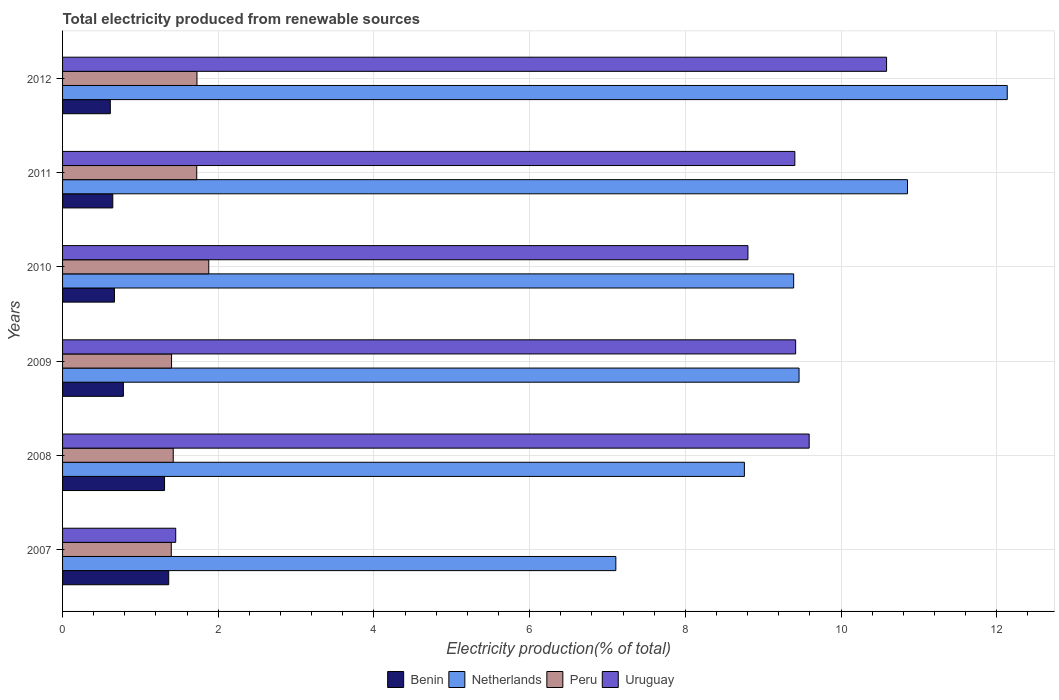How many different coloured bars are there?
Ensure brevity in your answer.  4. Are the number of bars on each tick of the Y-axis equal?
Offer a terse response. Yes. How many bars are there on the 6th tick from the top?
Give a very brief answer. 4. How many bars are there on the 5th tick from the bottom?
Give a very brief answer. 4. What is the label of the 4th group of bars from the top?
Give a very brief answer. 2009. What is the total electricity produced in Uruguay in 2007?
Your response must be concise. 1.45. Across all years, what is the maximum total electricity produced in Netherlands?
Ensure brevity in your answer.  12.14. Across all years, what is the minimum total electricity produced in Benin?
Make the answer very short. 0.61. In which year was the total electricity produced in Benin maximum?
Provide a succinct answer. 2007. In which year was the total electricity produced in Netherlands minimum?
Give a very brief answer. 2007. What is the total total electricity produced in Benin in the graph?
Your answer should be compact. 5.38. What is the difference between the total electricity produced in Benin in 2007 and that in 2009?
Your answer should be compact. 0.58. What is the difference between the total electricity produced in Uruguay in 2010 and the total electricity produced in Peru in 2012?
Provide a succinct answer. 7.08. What is the average total electricity produced in Peru per year?
Provide a succinct answer. 1.59. In the year 2009, what is the difference between the total electricity produced in Netherlands and total electricity produced in Uruguay?
Offer a terse response. 0.04. In how many years, is the total electricity produced in Uruguay greater than 2.4 %?
Provide a succinct answer. 5. What is the ratio of the total electricity produced in Benin in 2009 to that in 2012?
Keep it short and to the point. 1.27. What is the difference between the highest and the second highest total electricity produced in Peru?
Your answer should be very brief. 0.15. What is the difference between the highest and the lowest total electricity produced in Benin?
Your answer should be compact. 0.75. Is the sum of the total electricity produced in Uruguay in 2009 and 2011 greater than the maximum total electricity produced in Benin across all years?
Provide a succinct answer. Yes. Is it the case that in every year, the sum of the total electricity produced in Benin and total electricity produced in Uruguay is greater than the sum of total electricity produced in Peru and total electricity produced in Netherlands?
Keep it short and to the point. No. What does the 2nd bar from the top in 2012 represents?
Your answer should be very brief. Peru. How many bars are there?
Your answer should be compact. 24. Are all the bars in the graph horizontal?
Make the answer very short. Yes. Are the values on the major ticks of X-axis written in scientific E-notation?
Offer a terse response. No. How many legend labels are there?
Make the answer very short. 4. What is the title of the graph?
Your response must be concise. Total electricity produced from renewable sources. Does "Singapore" appear as one of the legend labels in the graph?
Your answer should be compact. No. What is the Electricity production(% of total) of Benin in 2007?
Your response must be concise. 1.36. What is the Electricity production(% of total) of Netherlands in 2007?
Ensure brevity in your answer.  7.11. What is the Electricity production(% of total) in Peru in 2007?
Keep it short and to the point. 1.4. What is the Electricity production(% of total) of Uruguay in 2007?
Make the answer very short. 1.45. What is the Electricity production(% of total) in Benin in 2008?
Provide a succinct answer. 1.31. What is the Electricity production(% of total) in Netherlands in 2008?
Your answer should be compact. 8.76. What is the Electricity production(% of total) in Peru in 2008?
Ensure brevity in your answer.  1.42. What is the Electricity production(% of total) of Uruguay in 2008?
Offer a very short reply. 9.59. What is the Electricity production(% of total) of Benin in 2009?
Your response must be concise. 0.78. What is the Electricity production(% of total) in Netherlands in 2009?
Ensure brevity in your answer.  9.46. What is the Electricity production(% of total) in Peru in 2009?
Give a very brief answer. 1.4. What is the Electricity production(% of total) of Uruguay in 2009?
Offer a terse response. 9.42. What is the Electricity production(% of total) of Benin in 2010?
Offer a terse response. 0.67. What is the Electricity production(% of total) in Netherlands in 2010?
Your answer should be very brief. 9.39. What is the Electricity production(% of total) in Peru in 2010?
Provide a short and direct response. 1.88. What is the Electricity production(% of total) of Uruguay in 2010?
Your answer should be very brief. 8.8. What is the Electricity production(% of total) of Benin in 2011?
Provide a short and direct response. 0.65. What is the Electricity production(% of total) of Netherlands in 2011?
Give a very brief answer. 10.85. What is the Electricity production(% of total) in Peru in 2011?
Offer a terse response. 1.72. What is the Electricity production(% of total) of Uruguay in 2011?
Offer a terse response. 9.41. What is the Electricity production(% of total) of Benin in 2012?
Provide a succinct answer. 0.61. What is the Electricity production(% of total) in Netherlands in 2012?
Your answer should be compact. 12.14. What is the Electricity production(% of total) in Peru in 2012?
Your answer should be very brief. 1.73. What is the Electricity production(% of total) of Uruguay in 2012?
Your response must be concise. 10.58. Across all years, what is the maximum Electricity production(% of total) in Benin?
Make the answer very short. 1.36. Across all years, what is the maximum Electricity production(% of total) of Netherlands?
Keep it short and to the point. 12.14. Across all years, what is the maximum Electricity production(% of total) in Peru?
Your answer should be compact. 1.88. Across all years, what is the maximum Electricity production(% of total) in Uruguay?
Give a very brief answer. 10.58. Across all years, what is the minimum Electricity production(% of total) in Benin?
Your response must be concise. 0.61. Across all years, what is the minimum Electricity production(% of total) in Netherlands?
Make the answer very short. 7.11. Across all years, what is the minimum Electricity production(% of total) in Peru?
Ensure brevity in your answer.  1.4. Across all years, what is the minimum Electricity production(% of total) in Uruguay?
Keep it short and to the point. 1.45. What is the total Electricity production(% of total) in Benin in the graph?
Your response must be concise. 5.38. What is the total Electricity production(% of total) in Netherlands in the graph?
Your response must be concise. 57.71. What is the total Electricity production(% of total) of Peru in the graph?
Your answer should be compact. 9.55. What is the total Electricity production(% of total) of Uruguay in the graph?
Keep it short and to the point. 49.26. What is the difference between the Electricity production(% of total) of Benin in 2007 and that in 2008?
Your answer should be compact. 0.05. What is the difference between the Electricity production(% of total) of Netherlands in 2007 and that in 2008?
Your answer should be very brief. -1.65. What is the difference between the Electricity production(% of total) in Peru in 2007 and that in 2008?
Offer a terse response. -0.03. What is the difference between the Electricity production(% of total) of Uruguay in 2007 and that in 2008?
Provide a succinct answer. -8.14. What is the difference between the Electricity production(% of total) of Benin in 2007 and that in 2009?
Your response must be concise. 0.58. What is the difference between the Electricity production(% of total) of Netherlands in 2007 and that in 2009?
Keep it short and to the point. -2.35. What is the difference between the Electricity production(% of total) in Peru in 2007 and that in 2009?
Your answer should be very brief. -0. What is the difference between the Electricity production(% of total) of Uruguay in 2007 and that in 2009?
Make the answer very short. -7.96. What is the difference between the Electricity production(% of total) of Benin in 2007 and that in 2010?
Provide a succinct answer. 0.7. What is the difference between the Electricity production(% of total) in Netherlands in 2007 and that in 2010?
Provide a succinct answer. -2.28. What is the difference between the Electricity production(% of total) of Peru in 2007 and that in 2010?
Ensure brevity in your answer.  -0.48. What is the difference between the Electricity production(% of total) of Uruguay in 2007 and that in 2010?
Your answer should be compact. -7.35. What is the difference between the Electricity production(% of total) of Benin in 2007 and that in 2011?
Your answer should be compact. 0.72. What is the difference between the Electricity production(% of total) in Netherlands in 2007 and that in 2011?
Offer a very short reply. -3.75. What is the difference between the Electricity production(% of total) of Peru in 2007 and that in 2011?
Your answer should be very brief. -0.33. What is the difference between the Electricity production(% of total) of Uruguay in 2007 and that in 2011?
Offer a very short reply. -7.95. What is the difference between the Electricity production(% of total) in Benin in 2007 and that in 2012?
Provide a succinct answer. 0.75. What is the difference between the Electricity production(% of total) in Netherlands in 2007 and that in 2012?
Give a very brief answer. -5.03. What is the difference between the Electricity production(% of total) of Peru in 2007 and that in 2012?
Your answer should be very brief. -0.33. What is the difference between the Electricity production(% of total) in Uruguay in 2007 and that in 2012?
Keep it short and to the point. -9.13. What is the difference between the Electricity production(% of total) of Benin in 2008 and that in 2009?
Your answer should be compact. 0.53. What is the difference between the Electricity production(% of total) in Netherlands in 2008 and that in 2009?
Ensure brevity in your answer.  -0.7. What is the difference between the Electricity production(% of total) in Peru in 2008 and that in 2009?
Provide a short and direct response. 0.02. What is the difference between the Electricity production(% of total) in Uruguay in 2008 and that in 2009?
Ensure brevity in your answer.  0.17. What is the difference between the Electricity production(% of total) of Benin in 2008 and that in 2010?
Provide a short and direct response. 0.64. What is the difference between the Electricity production(% of total) of Netherlands in 2008 and that in 2010?
Ensure brevity in your answer.  -0.63. What is the difference between the Electricity production(% of total) of Peru in 2008 and that in 2010?
Ensure brevity in your answer.  -0.46. What is the difference between the Electricity production(% of total) of Uruguay in 2008 and that in 2010?
Keep it short and to the point. 0.79. What is the difference between the Electricity production(% of total) of Benin in 2008 and that in 2011?
Your answer should be compact. 0.66. What is the difference between the Electricity production(% of total) of Netherlands in 2008 and that in 2011?
Provide a succinct answer. -2.1. What is the difference between the Electricity production(% of total) in Peru in 2008 and that in 2011?
Give a very brief answer. -0.3. What is the difference between the Electricity production(% of total) in Uruguay in 2008 and that in 2011?
Keep it short and to the point. 0.18. What is the difference between the Electricity production(% of total) of Benin in 2008 and that in 2012?
Keep it short and to the point. 0.7. What is the difference between the Electricity production(% of total) of Netherlands in 2008 and that in 2012?
Your answer should be very brief. -3.38. What is the difference between the Electricity production(% of total) in Peru in 2008 and that in 2012?
Provide a succinct answer. -0.3. What is the difference between the Electricity production(% of total) in Uruguay in 2008 and that in 2012?
Your answer should be compact. -0.99. What is the difference between the Electricity production(% of total) of Benin in 2009 and that in 2010?
Ensure brevity in your answer.  0.11. What is the difference between the Electricity production(% of total) in Netherlands in 2009 and that in 2010?
Provide a succinct answer. 0.07. What is the difference between the Electricity production(% of total) in Peru in 2009 and that in 2010?
Offer a terse response. -0.48. What is the difference between the Electricity production(% of total) in Uruguay in 2009 and that in 2010?
Ensure brevity in your answer.  0.61. What is the difference between the Electricity production(% of total) of Benin in 2009 and that in 2011?
Provide a short and direct response. 0.14. What is the difference between the Electricity production(% of total) in Netherlands in 2009 and that in 2011?
Offer a very short reply. -1.39. What is the difference between the Electricity production(% of total) of Peru in 2009 and that in 2011?
Your answer should be very brief. -0.32. What is the difference between the Electricity production(% of total) in Uruguay in 2009 and that in 2011?
Your answer should be compact. 0.01. What is the difference between the Electricity production(% of total) of Benin in 2009 and that in 2012?
Your answer should be compact. 0.17. What is the difference between the Electricity production(% of total) in Netherlands in 2009 and that in 2012?
Make the answer very short. -2.67. What is the difference between the Electricity production(% of total) of Peru in 2009 and that in 2012?
Your answer should be very brief. -0.33. What is the difference between the Electricity production(% of total) of Uruguay in 2009 and that in 2012?
Offer a very short reply. -1.17. What is the difference between the Electricity production(% of total) in Benin in 2010 and that in 2011?
Your response must be concise. 0.02. What is the difference between the Electricity production(% of total) of Netherlands in 2010 and that in 2011?
Offer a very short reply. -1.46. What is the difference between the Electricity production(% of total) in Peru in 2010 and that in 2011?
Offer a terse response. 0.15. What is the difference between the Electricity production(% of total) in Uruguay in 2010 and that in 2011?
Your answer should be compact. -0.6. What is the difference between the Electricity production(% of total) in Benin in 2010 and that in 2012?
Provide a short and direct response. 0.05. What is the difference between the Electricity production(% of total) of Netherlands in 2010 and that in 2012?
Offer a terse response. -2.74. What is the difference between the Electricity production(% of total) of Peru in 2010 and that in 2012?
Make the answer very short. 0.15. What is the difference between the Electricity production(% of total) of Uruguay in 2010 and that in 2012?
Give a very brief answer. -1.78. What is the difference between the Electricity production(% of total) of Benin in 2011 and that in 2012?
Your answer should be very brief. 0.03. What is the difference between the Electricity production(% of total) in Netherlands in 2011 and that in 2012?
Offer a terse response. -1.28. What is the difference between the Electricity production(% of total) of Peru in 2011 and that in 2012?
Ensure brevity in your answer.  -0. What is the difference between the Electricity production(% of total) in Uruguay in 2011 and that in 2012?
Keep it short and to the point. -1.18. What is the difference between the Electricity production(% of total) in Benin in 2007 and the Electricity production(% of total) in Netherlands in 2008?
Your answer should be very brief. -7.39. What is the difference between the Electricity production(% of total) of Benin in 2007 and the Electricity production(% of total) of Peru in 2008?
Provide a succinct answer. -0.06. What is the difference between the Electricity production(% of total) in Benin in 2007 and the Electricity production(% of total) in Uruguay in 2008?
Keep it short and to the point. -8.23. What is the difference between the Electricity production(% of total) in Netherlands in 2007 and the Electricity production(% of total) in Peru in 2008?
Provide a succinct answer. 5.69. What is the difference between the Electricity production(% of total) of Netherlands in 2007 and the Electricity production(% of total) of Uruguay in 2008?
Provide a succinct answer. -2.48. What is the difference between the Electricity production(% of total) in Peru in 2007 and the Electricity production(% of total) in Uruguay in 2008?
Make the answer very short. -8.19. What is the difference between the Electricity production(% of total) in Benin in 2007 and the Electricity production(% of total) in Netherlands in 2009?
Give a very brief answer. -8.1. What is the difference between the Electricity production(% of total) of Benin in 2007 and the Electricity production(% of total) of Peru in 2009?
Ensure brevity in your answer.  -0.04. What is the difference between the Electricity production(% of total) in Benin in 2007 and the Electricity production(% of total) in Uruguay in 2009?
Keep it short and to the point. -8.05. What is the difference between the Electricity production(% of total) in Netherlands in 2007 and the Electricity production(% of total) in Peru in 2009?
Give a very brief answer. 5.71. What is the difference between the Electricity production(% of total) of Netherlands in 2007 and the Electricity production(% of total) of Uruguay in 2009?
Make the answer very short. -2.31. What is the difference between the Electricity production(% of total) in Peru in 2007 and the Electricity production(% of total) in Uruguay in 2009?
Provide a short and direct response. -8.02. What is the difference between the Electricity production(% of total) of Benin in 2007 and the Electricity production(% of total) of Netherlands in 2010?
Your answer should be compact. -8.03. What is the difference between the Electricity production(% of total) of Benin in 2007 and the Electricity production(% of total) of Peru in 2010?
Give a very brief answer. -0.51. What is the difference between the Electricity production(% of total) in Benin in 2007 and the Electricity production(% of total) in Uruguay in 2010?
Provide a short and direct response. -7.44. What is the difference between the Electricity production(% of total) in Netherlands in 2007 and the Electricity production(% of total) in Peru in 2010?
Offer a terse response. 5.23. What is the difference between the Electricity production(% of total) in Netherlands in 2007 and the Electricity production(% of total) in Uruguay in 2010?
Offer a terse response. -1.7. What is the difference between the Electricity production(% of total) in Peru in 2007 and the Electricity production(% of total) in Uruguay in 2010?
Offer a very short reply. -7.41. What is the difference between the Electricity production(% of total) in Benin in 2007 and the Electricity production(% of total) in Netherlands in 2011?
Provide a short and direct response. -9.49. What is the difference between the Electricity production(% of total) of Benin in 2007 and the Electricity production(% of total) of Peru in 2011?
Make the answer very short. -0.36. What is the difference between the Electricity production(% of total) in Benin in 2007 and the Electricity production(% of total) in Uruguay in 2011?
Offer a terse response. -8.04. What is the difference between the Electricity production(% of total) of Netherlands in 2007 and the Electricity production(% of total) of Peru in 2011?
Provide a succinct answer. 5.38. What is the difference between the Electricity production(% of total) in Netherlands in 2007 and the Electricity production(% of total) in Uruguay in 2011?
Your response must be concise. -2.3. What is the difference between the Electricity production(% of total) in Peru in 2007 and the Electricity production(% of total) in Uruguay in 2011?
Provide a short and direct response. -8.01. What is the difference between the Electricity production(% of total) in Benin in 2007 and the Electricity production(% of total) in Netherlands in 2012?
Ensure brevity in your answer.  -10.77. What is the difference between the Electricity production(% of total) of Benin in 2007 and the Electricity production(% of total) of Peru in 2012?
Offer a terse response. -0.36. What is the difference between the Electricity production(% of total) of Benin in 2007 and the Electricity production(% of total) of Uruguay in 2012?
Provide a succinct answer. -9.22. What is the difference between the Electricity production(% of total) in Netherlands in 2007 and the Electricity production(% of total) in Peru in 2012?
Offer a terse response. 5.38. What is the difference between the Electricity production(% of total) in Netherlands in 2007 and the Electricity production(% of total) in Uruguay in 2012?
Give a very brief answer. -3.48. What is the difference between the Electricity production(% of total) of Peru in 2007 and the Electricity production(% of total) of Uruguay in 2012?
Provide a succinct answer. -9.19. What is the difference between the Electricity production(% of total) of Benin in 2008 and the Electricity production(% of total) of Netherlands in 2009?
Make the answer very short. -8.15. What is the difference between the Electricity production(% of total) of Benin in 2008 and the Electricity production(% of total) of Peru in 2009?
Your answer should be compact. -0.09. What is the difference between the Electricity production(% of total) in Benin in 2008 and the Electricity production(% of total) in Uruguay in 2009?
Offer a very short reply. -8.11. What is the difference between the Electricity production(% of total) of Netherlands in 2008 and the Electricity production(% of total) of Peru in 2009?
Offer a very short reply. 7.36. What is the difference between the Electricity production(% of total) of Netherlands in 2008 and the Electricity production(% of total) of Uruguay in 2009?
Provide a succinct answer. -0.66. What is the difference between the Electricity production(% of total) of Peru in 2008 and the Electricity production(% of total) of Uruguay in 2009?
Give a very brief answer. -8. What is the difference between the Electricity production(% of total) in Benin in 2008 and the Electricity production(% of total) in Netherlands in 2010?
Your answer should be compact. -8.08. What is the difference between the Electricity production(% of total) in Benin in 2008 and the Electricity production(% of total) in Peru in 2010?
Provide a short and direct response. -0.57. What is the difference between the Electricity production(% of total) of Benin in 2008 and the Electricity production(% of total) of Uruguay in 2010?
Your answer should be compact. -7.49. What is the difference between the Electricity production(% of total) of Netherlands in 2008 and the Electricity production(% of total) of Peru in 2010?
Your answer should be very brief. 6.88. What is the difference between the Electricity production(% of total) in Netherlands in 2008 and the Electricity production(% of total) in Uruguay in 2010?
Ensure brevity in your answer.  -0.05. What is the difference between the Electricity production(% of total) of Peru in 2008 and the Electricity production(% of total) of Uruguay in 2010?
Ensure brevity in your answer.  -7.38. What is the difference between the Electricity production(% of total) of Benin in 2008 and the Electricity production(% of total) of Netherlands in 2011?
Make the answer very short. -9.54. What is the difference between the Electricity production(% of total) in Benin in 2008 and the Electricity production(% of total) in Peru in 2011?
Your answer should be compact. -0.41. What is the difference between the Electricity production(% of total) in Benin in 2008 and the Electricity production(% of total) in Uruguay in 2011?
Give a very brief answer. -8.1. What is the difference between the Electricity production(% of total) of Netherlands in 2008 and the Electricity production(% of total) of Peru in 2011?
Give a very brief answer. 7.03. What is the difference between the Electricity production(% of total) in Netherlands in 2008 and the Electricity production(% of total) in Uruguay in 2011?
Your response must be concise. -0.65. What is the difference between the Electricity production(% of total) in Peru in 2008 and the Electricity production(% of total) in Uruguay in 2011?
Provide a short and direct response. -7.98. What is the difference between the Electricity production(% of total) in Benin in 2008 and the Electricity production(% of total) in Netherlands in 2012?
Keep it short and to the point. -10.82. What is the difference between the Electricity production(% of total) of Benin in 2008 and the Electricity production(% of total) of Peru in 2012?
Offer a very short reply. -0.42. What is the difference between the Electricity production(% of total) in Benin in 2008 and the Electricity production(% of total) in Uruguay in 2012?
Ensure brevity in your answer.  -9.27. What is the difference between the Electricity production(% of total) of Netherlands in 2008 and the Electricity production(% of total) of Peru in 2012?
Your response must be concise. 7.03. What is the difference between the Electricity production(% of total) of Netherlands in 2008 and the Electricity production(% of total) of Uruguay in 2012?
Give a very brief answer. -1.83. What is the difference between the Electricity production(% of total) of Peru in 2008 and the Electricity production(% of total) of Uruguay in 2012?
Offer a very short reply. -9.16. What is the difference between the Electricity production(% of total) of Benin in 2009 and the Electricity production(% of total) of Netherlands in 2010?
Ensure brevity in your answer.  -8.61. What is the difference between the Electricity production(% of total) of Benin in 2009 and the Electricity production(% of total) of Peru in 2010?
Your answer should be very brief. -1.1. What is the difference between the Electricity production(% of total) in Benin in 2009 and the Electricity production(% of total) in Uruguay in 2010?
Make the answer very short. -8.02. What is the difference between the Electricity production(% of total) of Netherlands in 2009 and the Electricity production(% of total) of Peru in 2010?
Your answer should be very brief. 7.58. What is the difference between the Electricity production(% of total) of Netherlands in 2009 and the Electricity production(% of total) of Uruguay in 2010?
Offer a terse response. 0.66. What is the difference between the Electricity production(% of total) in Peru in 2009 and the Electricity production(% of total) in Uruguay in 2010?
Your response must be concise. -7.4. What is the difference between the Electricity production(% of total) in Benin in 2009 and the Electricity production(% of total) in Netherlands in 2011?
Offer a very short reply. -10.07. What is the difference between the Electricity production(% of total) in Benin in 2009 and the Electricity production(% of total) in Peru in 2011?
Offer a very short reply. -0.94. What is the difference between the Electricity production(% of total) in Benin in 2009 and the Electricity production(% of total) in Uruguay in 2011?
Provide a succinct answer. -8.63. What is the difference between the Electricity production(% of total) of Netherlands in 2009 and the Electricity production(% of total) of Peru in 2011?
Ensure brevity in your answer.  7.74. What is the difference between the Electricity production(% of total) of Netherlands in 2009 and the Electricity production(% of total) of Uruguay in 2011?
Your answer should be very brief. 0.05. What is the difference between the Electricity production(% of total) of Peru in 2009 and the Electricity production(% of total) of Uruguay in 2011?
Your answer should be compact. -8.01. What is the difference between the Electricity production(% of total) in Benin in 2009 and the Electricity production(% of total) in Netherlands in 2012?
Ensure brevity in your answer.  -11.35. What is the difference between the Electricity production(% of total) of Benin in 2009 and the Electricity production(% of total) of Peru in 2012?
Offer a very short reply. -0.95. What is the difference between the Electricity production(% of total) in Benin in 2009 and the Electricity production(% of total) in Uruguay in 2012?
Offer a very short reply. -9.8. What is the difference between the Electricity production(% of total) of Netherlands in 2009 and the Electricity production(% of total) of Peru in 2012?
Give a very brief answer. 7.73. What is the difference between the Electricity production(% of total) in Netherlands in 2009 and the Electricity production(% of total) in Uruguay in 2012?
Offer a terse response. -1.12. What is the difference between the Electricity production(% of total) in Peru in 2009 and the Electricity production(% of total) in Uruguay in 2012?
Offer a terse response. -9.18. What is the difference between the Electricity production(% of total) in Benin in 2010 and the Electricity production(% of total) in Netherlands in 2011?
Your answer should be compact. -10.19. What is the difference between the Electricity production(% of total) in Benin in 2010 and the Electricity production(% of total) in Peru in 2011?
Your answer should be compact. -1.06. What is the difference between the Electricity production(% of total) in Benin in 2010 and the Electricity production(% of total) in Uruguay in 2011?
Your response must be concise. -8.74. What is the difference between the Electricity production(% of total) in Netherlands in 2010 and the Electricity production(% of total) in Peru in 2011?
Offer a terse response. 7.67. What is the difference between the Electricity production(% of total) of Netherlands in 2010 and the Electricity production(% of total) of Uruguay in 2011?
Offer a terse response. -0.01. What is the difference between the Electricity production(% of total) in Peru in 2010 and the Electricity production(% of total) in Uruguay in 2011?
Your answer should be very brief. -7.53. What is the difference between the Electricity production(% of total) of Benin in 2010 and the Electricity production(% of total) of Netherlands in 2012?
Your answer should be compact. -11.47. What is the difference between the Electricity production(% of total) of Benin in 2010 and the Electricity production(% of total) of Peru in 2012?
Keep it short and to the point. -1.06. What is the difference between the Electricity production(% of total) in Benin in 2010 and the Electricity production(% of total) in Uruguay in 2012?
Your answer should be compact. -9.92. What is the difference between the Electricity production(% of total) of Netherlands in 2010 and the Electricity production(% of total) of Peru in 2012?
Your response must be concise. 7.67. What is the difference between the Electricity production(% of total) in Netherlands in 2010 and the Electricity production(% of total) in Uruguay in 2012?
Offer a terse response. -1.19. What is the difference between the Electricity production(% of total) of Peru in 2010 and the Electricity production(% of total) of Uruguay in 2012?
Your response must be concise. -8.71. What is the difference between the Electricity production(% of total) of Benin in 2011 and the Electricity production(% of total) of Netherlands in 2012?
Provide a short and direct response. -11.49. What is the difference between the Electricity production(% of total) in Benin in 2011 and the Electricity production(% of total) in Peru in 2012?
Offer a terse response. -1.08. What is the difference between the Electricity production(% of total) in Benin in 2011 and the Electricity production(% of total) in Uruguay in 2012?
Offer a very short reply. -9.94. What is the difference between the Electricity production(% of total) of Netherlands in 2011 and the Electricity production(% of total) of Peru in 2012?
Your response must be concise. 9.13. What is the difference between the Electricity production(% of total) of Netherlands in 2011 and the Electricity production(% of total) of Uruguay in 2012?
Your response must be concise. 0.27. What is the difference between the Electricity production(% of total) of Peru in 2011 and the Electricity production(% of total) of Uruguay in 2012?
Your answer should be very brief. -8.86. What is the average Electricity production(% of total) of Benin per year?
Ensure brevity in your answer.  0.9. What is the average Electricity production(% of total) in Netherlands per year?
Provide a succinct answer. 9.62. What is the average Electricity production(% of total) of Peru per year?
Keep it short and to the point. 1.59. What is the average Electricity production(% of total) in Uruguay per year?
Offer a very short reply. 8.21. In the year 2007, what is the difference between the Electricity production(% of total) in Benin and Electricity production(% of total) in Netherlands?
Provide a succinct answer. -5.74. In the year 2007, what is the difference between the Electricity production(% of total) in Benin and Electricity production(% of total) in Peru?
Offer a very short reply. -0.03. In the year 2007, what is the difference between the Electricity production(% of total) in Benin and Electricity production(% of total) in Uruguay?
Your answer should be very brief. -0.09. In the year 2007, what is the difference between the Electricity production(% of total) in Netherlands and Electricity production(% of total) in Peru?
Provide a short and direct response. 5.71. In the year 2007, what is the difference between the Electricity production(% of total) of Netherlands and Electricity production(% of total) of Uruguay?
Your answer should be compact. 5.65. In the year 2007, what is the difference between the Electricity production(% of total) of Peru and Electricity production(% of total) of Uruguay?
Provide a succinct answer. -0.06. In the year 2008, what is the difference between the Electricity production(% of total) of Benin and Electricity production(% of total) of Netherlands?
Your answer should be compact. -7.45. In the year 2008, what is the difference between the Electricity production(% of total) in Benin and Electricity production(% of total) in Peru?
Make the answer very short. -0.11. In the year 2008, what is the difference between the Electricity production(% of total) of Benin and Electricity production(% of total) of Uruguay?
Your answer should be very brief. -8.28. In the year 2008, what is the difference between the Electricity production(% of total) of Netherlands and Electricity production(% of total) of Peru?
Make the answer very short. 7.34. In the year 2008, what is the difference between the Electricity production(% of total) in Netherlands and Electricity production(% of total) in Uruguay?
Your answer should be very brief. -0.83. In the year 2008, what is the difference between the Electricity production(% of total) of Peru and Electricity production(% of total) of Uruguay?
Your answer should be compact. -8.17. In the year 2009, what is the difference between the Electricity production(% of total) of Benin and Electricity production(% of total) of Netherlands?
Ensure brevity in your answer.  -8.68. In the year 2009, what is the difference between the Electricity production(% of total) in Benin and Electricity production(% of total) in Peru?
Provide a short and direct response. -0.62. In the year 2009, what is the difference between the Electricity production(% of total) of Benin and Electricity production(% of total) of Uruguay?
Make the answer very short. -8.64. In the year 2009, what is the difference between the Electricity production(% of total) of Netherlands and Electricity production(% of total) of Peru?
Offer a very short reply. 8.06. In the year 2009, what is the difference between the Electricity production(% of total) in Netherlands and Electricity production(% of total) in Uruguay?
Your response must be concise. 0.04. In the year 2009, what is the difference between the Electricity production(% of total) in Peru and Electricity production(% of total) in Uruguay?
Offer a terse response. -8.02. In the year 2010, what is the difference between the Electricity production(% of total) of Benin and Electricity production(% of total) of Netherlands?
Your answer should be very brief. -8.72. In the year 2010, what is the difference between the Electricity production(% of total) of Benin and Electricity production(% of total) of Peru?
Your response must be concise. -1.21. In the year 2010, what is the difference between the Electricity production(% of total) in Benin and Electricity production(% of total) in Uruguay?
Make the answer very short. -8.14. In the year 2010, what is the difference between the Electricity production(% of total) of Netherlands and Electricity production(% of total) of Peru?
Your answer should be compact. 7.51. In the year 2010, what is the difference between the Electricity production(% of total) in Netherlands and Electricity production(% of total) in Uruguay?
Provide a succinct answer. 0.59. In the year 2010, what is the difference between the Electricity production(% of total) of Peru and Electricity production(% of total) of Uruguay?
Your response must be concise. -6.93. In the year 2011, what is the difference between the Electricity production(% of total) in Benin and Electricity production(% of total) in Netherlands?
Keep it short and to the point. -10.21. In the year 2011, what is the difference between the Electricity production(% of total) in Benin and Electricity production(% of total) in Peru?
Ensure brevity in your answer.  -1.08. In the year 2011, what is the difference between the Electricity production(% of total) of Benin and Electricity production(% of total) of Uruguay?
Give a very brief answer. -8.76. In the year 2011, what is the difference between the Electricity production(% of total) in Netherlands and Electricity production(% of total) in Peru?
Offer a very short reply. 9.13. In the year 2011, what is the difference between the Electricity production(% of total) in Netherlands and Electricity production(% of total) in Uruguay?
Give a very brief answer. 1.45. In the year 2011, what is the difference between the Electricity production(% of total) of Peru and Electricity production(% of total) of Uruguay?
Provide a succinct answer. -7.68. In the year 2012, what is the difference between the Electricity production(% of total) of Benin and Electricity production(% of total) of Netherlands?
Your answer should be very brief. -11.52. In the year 2012, what is the difference between the Electricity production(% of total) in Benin and Electricity production(% of total) in Peru?
Provide a succinct answer. -1.11. In the year 2012, what is the difference between the Electricity production(% of total) of Benin and Electricity production(% of total) of Uruguay?
Provide a succinct answer. -9.97. In the year 2012, what is the difference between the Electricity production(% of total) of Netherlands and Electricity production(% of total) of Peru?
Offer a very short reply. 10.41. In the year 2012, what is the difference between the Electricity production(% of total) of Netherlands and Electricity production(% of total) of Uruguay?
Provide a short and direct response. 1.55. In the year 2012, what is the difference between the Electricity production(% of total) in Peru and Electricity production(% of total) in Uruguay?
Make the answer very short. -8.86. What is the ratio of the Electricity production(% of total) in Benin in 2007 to that in 2008?
Offer a very short reply. 1.04. What is the ratio of the Electricity production(% of total) of Netherlands in 2007 to that in 2008?
Make the answer very short. 0.81. What is the ratio of the Electricity production(% of total) of Peru in 2007 to that in 2008?
Provide a short and direct response. 0.98. What is the ratio of the Electricity production(% of total) of Uruguay in 2007 to that in 2008?
Provide a succinct answer. 0.15. What is the ratio of the Electricity production(% of total) of Benin in 2007 to that in 2009?
Make the answer very short. 1.75. What is the ratio of the Electricity production(% of total) in Netherlands in 2007 to that in 2009?
Offer a terse response. 0.75. What is the ratio of the Electricity production(% of total) in Peru in 2007 to that in 2009?
Give a very brief answer. 1. What is the ratio of the Electricity production(% of total) in Uruguay in 2007 to that in 2009?
Offer a terse response. 0.15. What is the ratio of the Electricity production(% of total) in Benin in 2007 to that in 2010?
Your answer should be very brief. 2.05. What is the ratio of the Electricity production(% of total) in Netherlands in 2007 to that in 2010?
Keep it short and to the point. 0.76. What is the ratio of the Electricity production(% of total) in Peru in 2007 to that in 2010?
Provide a short and direct response. 0.74. What is the ratio of the Electricity production(% of total) in Uruguay in 2007 to that in 2010?
Your answer should be compact. 0.17. What is the ratio of the Electricity production(% of total) of Benin in 2007 to that in 2011?
Make the answer very short. 2.11. What is the ratio of the Electricity production(% of total) in Netherlands in 2007 to that in 2011?
Offer a very short reply. 0.65. What is the ratio of the Electricity production(% of total) of Peru in 2007 to that in 2011?
Offer a very short reply. 0.81. What is the ratio of the Electricity production(% of total) of Uruguay in 2007 to that in 2011?
Your response must be concise. 0.15. What is the ratio of the Electricity production(% of total) of Benin in 2007 to that in 2012?
Provide a succinct answer. 2.22. What is the ratio of the Electricity production(% of total) in Netherlands in 2007 to that in 2012?
Your response must be concise. 0.59. What is the ratio of the Electricity production(% of total) of Peru in 2007 to that in 2012?
Offer a very short reply. 0.81. What is the ratio of the Electricity production(% of total) in Uruguay in 2007 to that in 2012?
Make the answer very short. 0.14. What is the ratio of the Electricity production(% of total) in Benin in 2008 to that in 2009?
Your response must be concise. 1.68. What is the ratio of the Electricity production(% of total) of Netherlands in 2008 to that in 2009?
Give a very brief answer. 0.93. What is the ratio of the Electricity production(% of total) in Peru in 2008 to that in 2009?
Make the answer very short. 1.02. What is the ratio of the Electricity production(% of total) in Uruguay in 2008 to that in 2009?
Provide a succinct answer. 1.02. What is the ratio of the Electricity production(% of total) in Benin in 2008 to that in 2010?
Give a very brief answer. 1.97. What is the ratio of the Electricity production(% of total) in Netherlands in 2008 to that in 2010?
Provide a short and direct response. 0.93. What is the ratio of the Electricity production(% of total) in Peru in 2008 to that in 2010?
Offer a terse response. 0.76. What is the ratio of the Electricity production(% of total) of Uruguay in 2008 to that in 2010?
Provide a short and direct response. 1.09. What is the ratio of the Electricity production(% of total) of Benin in 2008 to that in 2011?
Provide a succinct answer. 2.03. What is the ratio of the Electricity production(% of total) in Netherlands in 2008 to that in 2011?
Your answer should be very brief. 0.81. What is the ratio of the Electricity production(% of total) in Peru in 2008 to that in 2011?
Keep it short and to the point. 0.82. What is the ratio of the Electricity production(% of total) of Uruguay in 2008 to that in 2011?
Give a very brief answer. 1.02. What is the ratio of the Electricity production(% of total) of Benin in 2008 to that in 2012?
Offer a terse response. 2.14. What is the ratio of the Electricity production(% of total) of Netherlands in 2008 to that in 2012?
Keep it short and to the point. 0.72. What is the ratio of the Electricity production(% of total) in Peru in 2008 to that in 2012?
Provide a succinct answer. 0.82. What is the ratio of the Electricity production(% of total) in Uruguay in 2008 to that in 2012?
Your answer should be very brief. 0.91. What is the ratio of the Electricity production(% of total) of Benin in 2009 to that in 2010?
Ensure brevity in your answer.  1.17. What is the ratio of the Electricity production(% of total) of Netherlands in 2009 to that in 2010?
Your response must be concise. 1.01. What is the ratio of the Electricity production(% of total) of Peru in 2009 to that in 2010?
Provide a succinct answer. 0.75. What is the ratio of the Electricity production(% of total) in Uruguay in 2009 to that in 2010?
Provide a short and direct response. 1.07. What is the ratio of the Electricity production(% of total) of Benin in 2009 to that in 2011?
Offer a terse response. 1.21. What is the ratio of the Electricity production(% of total) in Netherlands in 2009 to that in 2011?
Your answer should be very brief. 0.87. What is the ratio of the Electricity production(% of total) of Peru in 2009 to that in 2011?
Your answer should be compact. 0.81. What is the ratio of the Electricity production(% of total) in Uruguay in 2009 to that in 2011?
Your answer should be very brief. 1. What is the ratio of the Electricity production(% of total) in Benin in 2009 to that in 2012?
Ensure brevity in your answer.  1.27. What is the ratio of the Electricity production(% of total) in Netherlands in 2009 to that in 2012?
Your answer should be very brief. 0.78. What is the ratio of the Electricity production(% of total) of Peru in 2009 to that in 2012?
Your answer should be compact. 0.81. What is the ratio of the Electricity production(% of total) in Uruguay in 2009 to that in 2012?
Your response must be concise. 0.89. What is the ratio of the Electricity production(% of total) in Netherlands in 2010 to that in 2011?
Ensure brevity in your answer.  0.87. What is the ratio of the Electricity production(% of total) in Peru in 2010 to that in 2011?
Ensure brevity in your answer.  1.09. What is the ratio of the Electricity production(% of total) in Uruguay in 2010 to that in 2011?
Provide a short and direct response. 0.94. What is the ratio of the Electricity production(% of total) of Benin in 2010 to that in 2012?
Offer a terse response. 1.09. What is the ratio of the Electricity production(% of total) of Netherlands in 2010 to that in 2012?
Provide a succinct answer. 0.77. What is the ratio of the Electricity production(% of total) in Peru in 2010 to that in 2012?
Make the answer very short. 1.09. What is the ratio of the Electricity production(% of total) of Uruguay in 2010 to that in 2012?
Make the answer very short. 0.83. What is the ratio of the Electricity production(% of total) of Benin in 2011 to that in 2012?
Provide a succinct answer. 1.05. What is the ratio of the Electricity production(% of total) in Netherlands in 2011 to that in 2012?
Give a very brief answer. 0.89. What is the ratio of the Electricity production(% of total) of Peru in 2011 to that in 2012?
Your answer should be very brief. 1. What is the ratio of the Electricity production(% of total) of Uruguay in 2011 to that in 2012?
Your answer should be very brief. 0.89. What is the difference between the highest and the second highest Electricity production(% of total) in Benin?
Make the answer very short. 0.05. What is the difference between the highest and the second highest Electricity production(% of total) of Netherlands?
Give a very brief answer. 1.28. What is the difference between the highest and the second highest Electricity production(% of total) in Peru?
Offer a terse response. 0.15. What is the difference between the highest and the second highest Electricity production(% of total) of Uruguay?
Offer a terse response. 0.99. What is the difference between the highest and the lowest Electricity production(% of total) of Benin?
Provide a short and direct response. 0.75. What is the difference between the highest and the lowest Electricity production(% of total) of Netherlands?
Provide a short and direct response. 5.03. What is the difference between the highest and the lowest Electricity production(% of total) of Peru?
Your answer should be compact. 0.48. What is the difference between the highest and the lowest Electricity production(% of total) in Uruguay?
Make the answer very short. 9.13. 